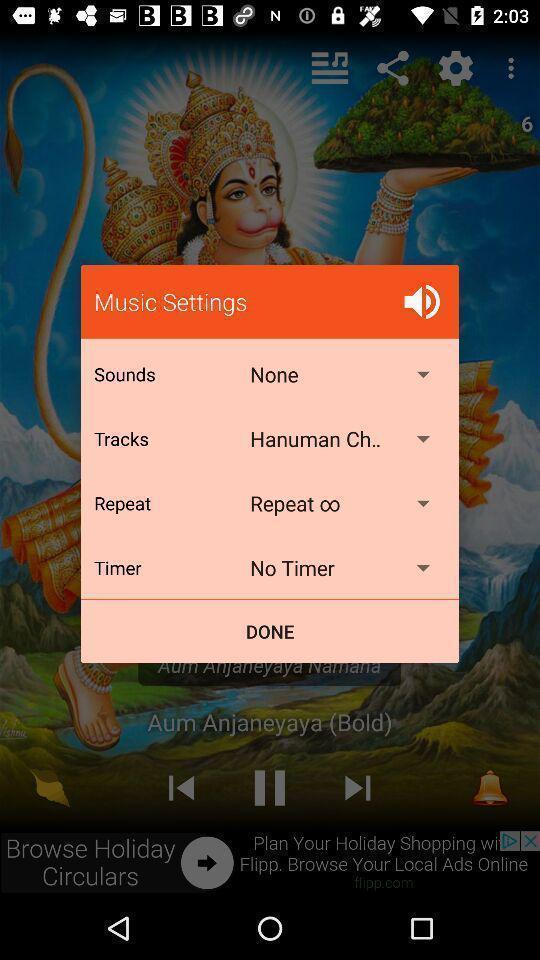What can you discern from this picture? Pop-up showing music settings in a music app. 